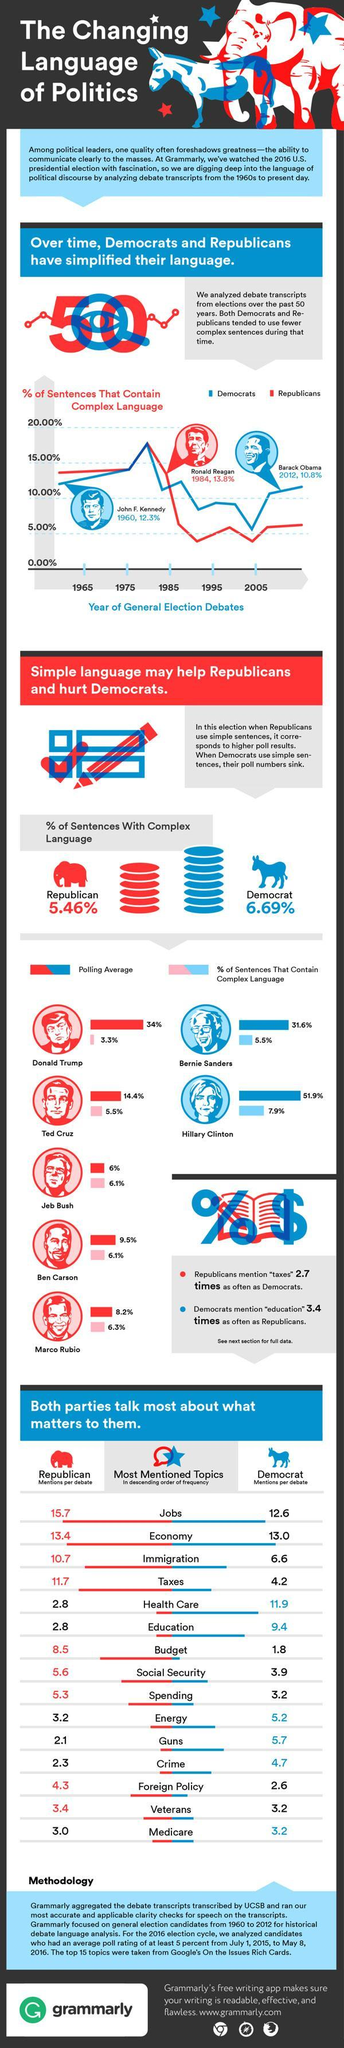What was the highest percentage of complex sentences used by the Democrats and Republicans in 1980s, 15%, 16.1% or 17.2%?
Answer the question with a short phrase. 17.2% Who had the least percentage of complex sentences during polls? Donald Trump Which was the most mentioned topic per debate among the Democrats? Health Care Who used a simple language during general election debates, Kennedy, Reagan, or Obama? Obama What was the highest average polling in the 2016 general elections? 51.9% Who was the only woman candidate in General elections 2016? Hillary Clinton Which party had a lower percentage of complex sentence in 2005? Republicans Which was the least mentioned topic per debate among the Republicans? Veterans 